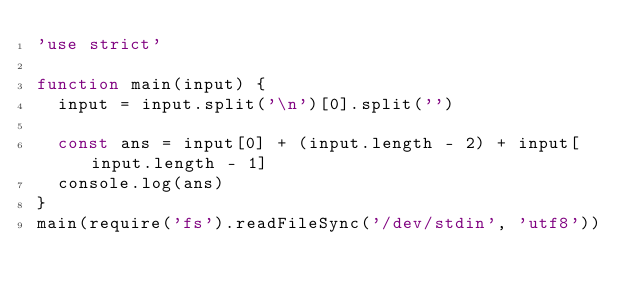Convert code to text. <code><loc_0><loc_0><loc_500><loc_500><_JavaScript_>'use strict'

function main(input) {
  input = input.split('\n')[0].split('')

  const ans = input[0] + (input.length - 2) + input[input.length - 1]
  console.log(ans)
}
main(require('fs').readFileSync('/dev/stdin', 'utf8'))</code> 